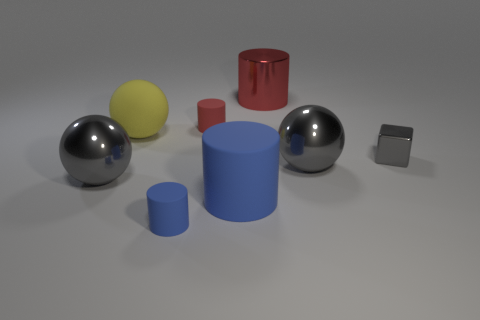Add 1 large objects. How many objects exist? 9 Subtract all cubes. How many objects are left? 7 Subtract 0 purple cylinders. How many objects are left? 8 Subtract all large gray rubber cubes. Subtract all big blue things. How many objects are left? 7 Add 2 blue matte objects. How many blue matte objects are left? 4 Add 2 tiny blue metallic balls. How many tiny blue metallic balls exist? 2 